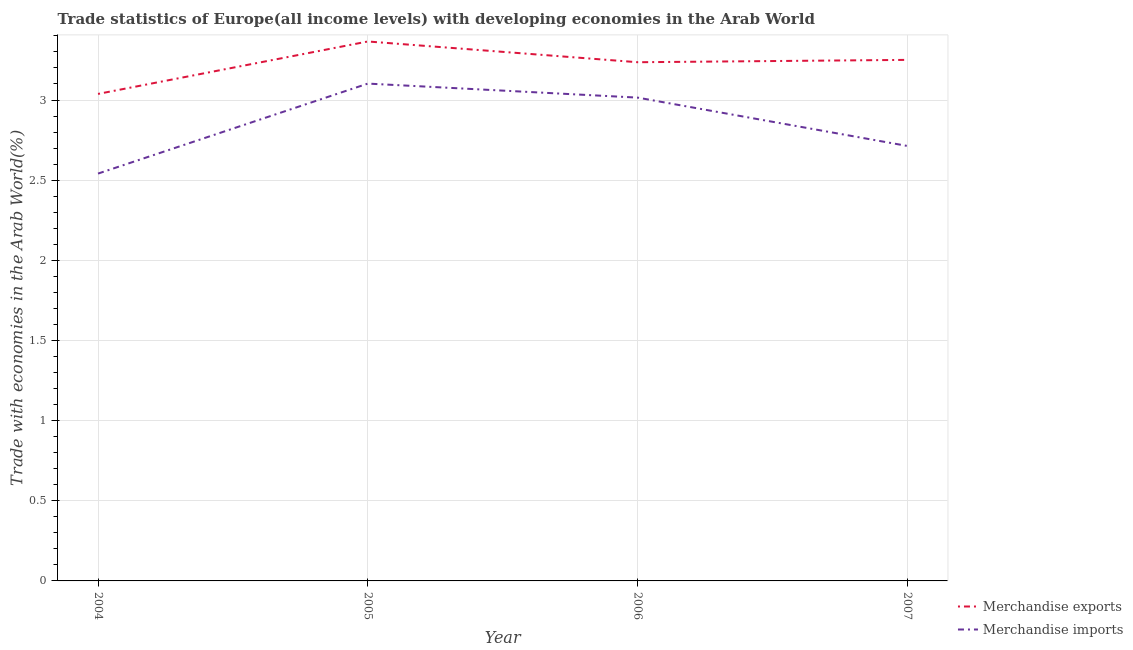How many different coloured lines are there?
Offer a very short reply. 2. Is the number of lines equal to the number of legend labels?
Offer a terse response. Yes. What is the merchandise exports in 2005?
Offer a very short reply. 3.37. Across all years, what is the maximum merchandise imports?
Your answer should be very brief. 3.1. Across all years, what is the minimum merchandise imports?
Provide a succinct answer. 2.54. In which year was the merchandise imports maximum?
Your answer should be very brief. 2005. In which year was the merchandise imports minimum?
Provide a short and direct response. 2004. What is the total merchandise imports in the graph?
Your response must be concise. 11.37. What is the difference between the merchandise imports in 2005 and that in 2007?
Your answer should be very brief. 0.39. What is the difference between the merchandise exports in 2007 and the merchandise imports in 2006?
Your response must be concise. 0.24. What is the average merchandise imports per year?
Provide a succinct answer. 2.84. In the year 2006, what is the difference between the merchandise imports and merchandise exports?
Make the answer very short. -0.22. What is the ratio of the merchandise imports in 2004 to that in 2007?
Your answer should be compact. 0.94. What is the difference between the highest and the second highest merchandise imports?
Ensure brevity in your answer.  0.09. What is the difference between the highest and the lowest merchandise exports?
Give a very brief answer. 0.33. How many lines are there?
Ensure brevity in your answer.  2. Does the graph contain any zero values?
Your answer should be compact. No. Where does the legend appear in the graph?
Your answer should be compact. Bottom right. How are the legend labels stacked?
Give a very brief answer. Vertical. What is the title of the graph?
Ensure brevity in your answer.  Trade statistics of Europe(all income levels) with developing economies in the Arab World. Does "Birth rate" appear as one of the legend labels in the graph?
Provide a succinct answer. No. What is the label or title of the Y-axis?
Ensure brevity in your answer.  Trade with economies in the Arab World(%). What is the Trade with economies in the Arab World(%) in Merchandise exports in 2004?
Your response must be concise. 3.04. What is the Trade with economies in the Arab World(%) in Merchandise imports in 2004?
Provide a short and direct response. 2.54. What is the Trade with economies in the Arab World(%) in Merchandise exports in 2005?
Provide a succinct answer. 3.37. What is the Trade with economies in the Arab World(%) of Merchandise imports in 2005?
Provide a short and direct response. 3.1. What is the Trade with economies in the Arab World(%) in Merchandise exports in 2006?
Provide a short and direct response. 3.24. What is the Trade with economies in the Arab World(%) of Merchandise imports in 2006?
Provide a succinct answer. 3.01. What is the Trade with economies in the Arab World(%) of Merchandise exports in 2007?
Your response must be concise. 3.25. What is the Trade with economies in the Arab World(%) of Merchandise imports in 2007?
Offer a very short reply. 2.71. Across all years, what is the maximum Trade with economies in the Arab World(%) of Merchandise exports?
Provide a short and direct response. 3.37. Across all years, what is the maximum Trade with economies in the Arab World(%) of Merchandise imports?
Your answer should be very brief. 3.1. Across all years, what is the minimum Trade with economies in the Arab World(%) in Merchandise exports?
Your response must be concise. 3.04. Across all years, what is the minimum Trade with economies in the Arab World(%) in Merchandise imports?
Provide a succinct answer. 2.54. What is the total Trade with economies in the Arab World(%) of Merchandise exports in the graph?
Make the answer very short. 12.89. What is the total Trade with economies in the Arab World(%) in Merchandise imports in the graph?
Provide a short and direct response. 11.37. What is the difference between the Trade with economies in the Arab World(%) in Merchandise exports in 2004 and that in 2005?
Offer a terse response. -0.33. What is the difference between the Trade with economies in the Arab World(%) in Merchandise imports in 2004 and that in 2005?
Ensure brevity in your answer.  -0.56. What is the difference between the Trade with economies in the Arab World(%) of Merchandise exports in 2004 and that in 2006?
Your response must be concise. -0.2. What is the difference between the Trade with economies in the Arab World(%) in Merchandise imports in 2004 and that in 2006?
Your answer should be very brief. -0.47. What is the difference between the Trade with economies in the Arab World(%) of Merchandise exports in 2004 and that in 2007?
Give a very brief answer. -0.21. What is the difference between the Trade with economies in the Arab World(%) of Merchandise imports in 2004 and that in 2007?
Your answer should be very brief. -0.17. What is the difference between the Trade with economies in the Arab World(%) in Merchandise exports in 2005 and that in 2006?
Provide a succinct answer. 0.13. What is the difference between the Trade with economies in the Arab World(%) of Merchandise imports in 2005 and that in 2006?
Your response must be concise. 0.09. What is the difference between the Trade with economies in the Arab World(%) in Merchandise exports in 2005 and that in 2007?
Provide a succinct answer. 0.11. What is the difference between the Trade with economies in the Arab World(%) in Merchandise imports in 2005 and that in 2007?
Make the answer very short. 0.39. What is the difference between the Trade with economies in the Arab World(%) of Merchandise exports in 2006 and that in 2007?
Provide a succinct answer. -0.01. What is the difference between the Trade with economies in the Arab World(%) in Merchandise imports in 2006 and that in 2007?
Give a very brief answer. 0.3. What is the difference between the Trade with economies in the Arab World(%) in Merchandise exports in 2004 and the Trade with economies in the Arab World(%) in Merchandise imports in 2005?
Keep it short and to the point. -0.06. What is the difference between the Trade with economies in the Arab World(%) in Merchandise exports in 2004 and the Trade with economies in the Arab World(%) in Merchandise imports in 2006?
Keep it short and to the point. 0.02. What is the difference between the Trade with economies in the Arab World(%) in Merchandise exports in 2004 and the Trade with economies in the Arab World(%) in Merchandise imports in 2007?
Give a very brief answer. 0.32. What is the difference between the Trade with economies in the Arab World(%) in Merchandise exports in 2005 and the Trade with economies in the Arab World(%) in Merchandise imports in 2006?
Your answer should be compact. 0.35. What is the difference between the Trade with economies in the Arab World(%) of Merchandise exports in 2005 and the Trade with economies in the Arab World(%) of Merchandise imports in 2007?
Your answer should be compact. 0.65. What is the difference between the Trade with economies in the Arab World(%) in Merchandise exports in 2006 and the Trade with economies in the Arab World(%) in Merchandise imports in 2007?
Keep it short and to the point. 0.52. What is the average Trade with economies in the Arab World(%) of Merchandise exports per year?
Keep it short and to the point. 3.22. What is the average Trade with economies in the Arab World(%) in Merchandise imports per year?
Give a very brief answer. 2.84. In the year 2004, what is the difference between the Trade with economies in the Arab World(%) of Merchandise exports and Trade with economies in the Arab World(%) of Merchandise imports?
Offer a terse response. 0.5. In the year 2005, what is the difference between the Trade with economies in the Arab World(%) in Merchandise exports and Trade with economies in the Arab World(%) in Merchandise imports?
Offer a very short reply. 0.26. In the year 2006, what is the difference between the Trade with economies in the Arab World(%) in Merchandise exports and Trade with economies in the Arab World(%) in Merchandise imports?
Provide a succinct answer. 0.22. In the year 2007, what is the difference between the Trade with economies in the Arab World(%) in Merchandise exports and Trade with economies in the Arab World(%) in Merchandise imports?
Provide a short and direct response. 0.54. What is the ratio of the Trade with economies in the Arab World(%) in Merchandise exports in 2004 to that in 2005?
Provide a short and direct response. 0.9. What is the ratio of the Trade with economies in the Arab World(%) of Merchandise imports in 2004 to that in 2005?
Provide a succinct answer. 0.82. What is the ratio of the Trade with economies in the Arab World(%) in Merchandise exports in 2004 to that in 2006?
Offer a terse response. 0.94. What is the ratio of the Trade with economies in the Arab World(%) in Merchandise imports in 2004 to that in 2006?
Your answer should be compact. 0.84. What is the ratio of the Trade with economies in the Arab World(%) of Merchandise exports in 2004 to that in 2007?
Your response must be concise. 0.93. What is the ratio of the Trade with economies in the Arab World(%) of Merchandise imports in 2004 to that in 2007?
Give a very brief answer. 0.94. What is the ratio of the Trade with economies in the Arab World(%) in Merchandise exports in 2005 to that in 2006?
Give a very brief answer. 1.04. What is the ratio of the Trade with economies in the Arab World(%) of Merchandise imports in 2005 to that in 2006?
Make the answer very short. 1.03. What is the ratio of the Trade with economies in the Arab World(%) of Merchandise exports in 2005 to that in 2007?
Give a very brief answer. 1.04. What is the ratio of the Trade with economies in the Arab World(%) of Merchandise imports in 2005 to that in 2007?
Give a very brief answer. 1.14. What is the ratio of the Trade with economies in the Arab World(%) of Merchandise exports in 2006 to that in 2007?
Your response must be concise. 1. What is the ratio of the Trade with economies in the Arab World(%) in Merchandise imports in 2006 to that in 2007?
Make the answer very short. 1.11. What is the difference between the highest and the second highest Trade with economies in the Arab World(%) in Merchandise exports?
Your answer should be very brief. 0.11. What is the difference between the highest and the second highest Trade with economies in the Arab World(%) in Merchandise imports?
Your answer should be very brief. 0.09. What is the difference between the highest and the lowest Trade with economies in the Arab World(%) in Merchandise exports?
Your response must be concise. 0.33. What is the difference between the highest and the lowest Trade with economies in the Arab World(%) in Merchandise imports?
Ensure brevity in your answer.  0.56. 